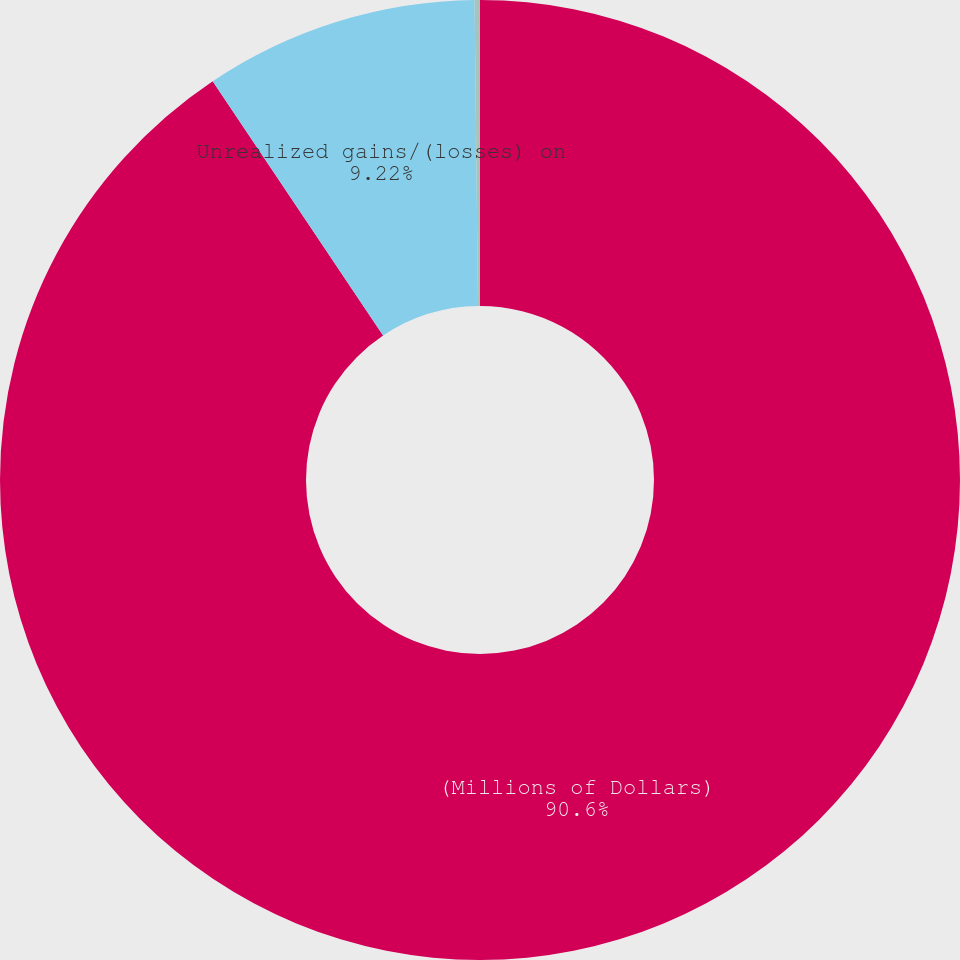<chart> <loc_0><loc_0><loc_500><loc_500><pie_chart><fcel>(Millions of Dollars)<fcel>Unrealized gains/(losses) on<fcel>Less Reclassification<nl><fcel>90.6%<fcel>9.22%<fcel>0.18%<nl></chart> 